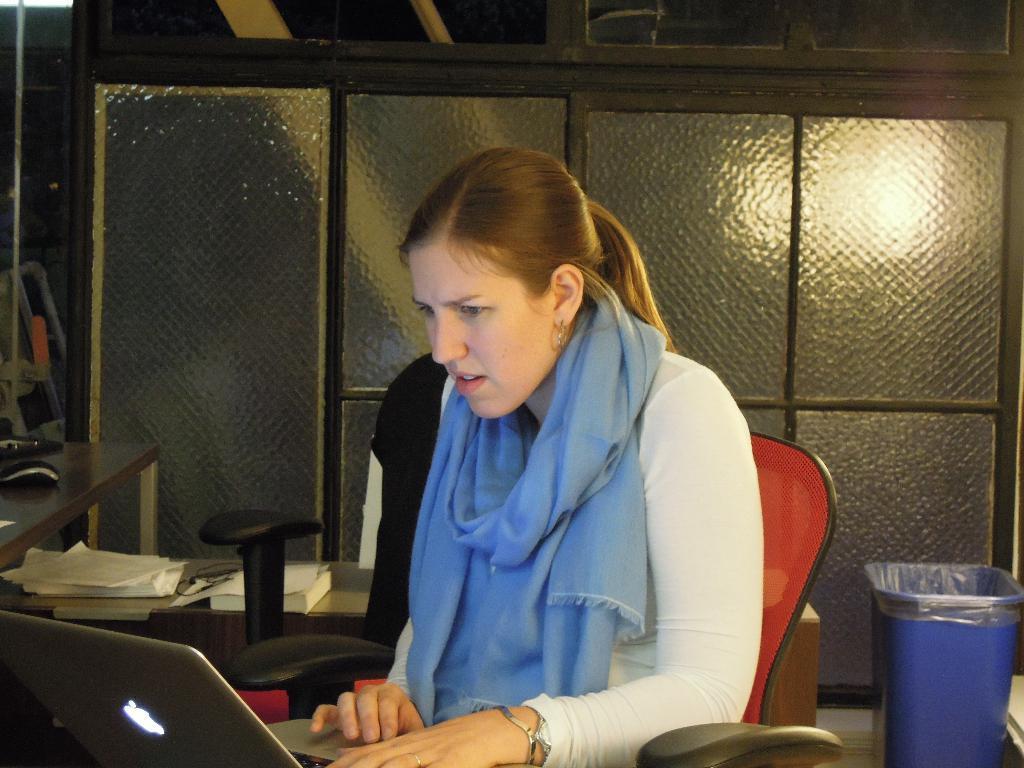How would you summarize this image in a sentence or two? She is sitting on a chair. She look at her laptop. We can see the background cupboard,dustbin. 